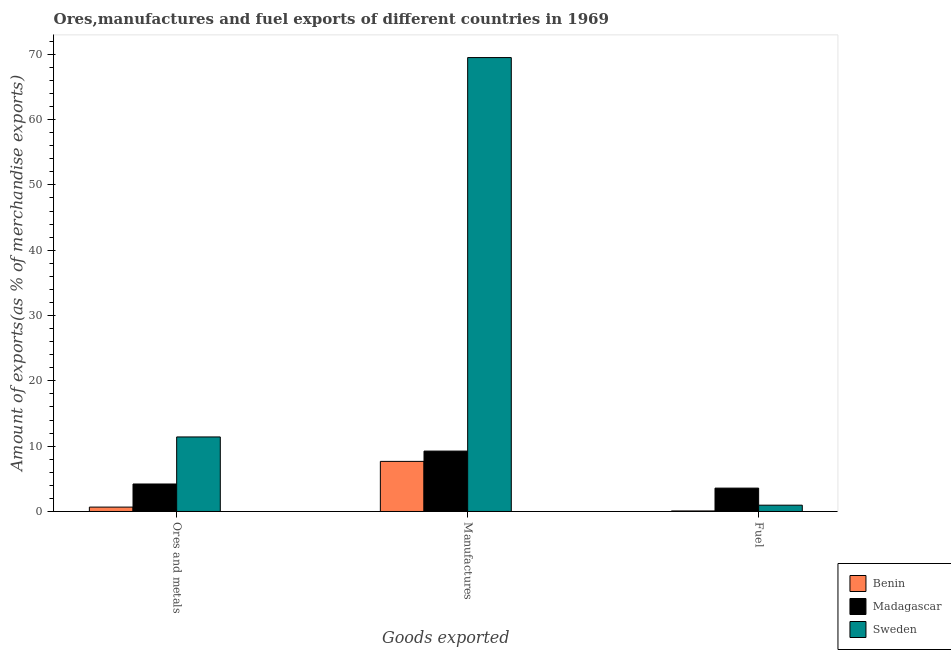How many different coloured bars are there?
Ensure brevity in your answer.  3. How many groups of bars are there?
Offer a terse response. 3. Are the number of bars per tick equal to the number of legend labels?
Your answer should be compact. Yes. Are the number of bars on each tick of the X-axis equal?
Your response must be concise. Yes. How many bars are there on the 3rd tick from the right?
Ensure brevity in your answer.  3. What is the label of the 1st group of bars from the left?
Provide a succinct answer. Ores and metals. What is the percentage of manufactures exports in Sweden?
Give a very brief answer. 69.5. Across all countries, what is the maximum percentage of ores and metals exports?
Your answer should be very brief. 11.41. Across all countries, what is the minimum percentage of manufactures exports?
Your answer should be very brief. 7.67. In which country was the percentage of ores and metals exports minimum?
Your response must be concise. Benin. What is the total percentage of manufactures exports in the graph?
Make the answer very short. 86.42. What is the difference between the percentage of fuel exports in Madagascar and that in Sweden?
Provide a succinct answer. 2.61. What is the difference between the percentage of manufactures exports in Sweden and the percentage of ores and metals exports in Madagascar?
Your answer should be compact. 65.29. What is the average percentage of fuel exports per country?
Your answer should be compact. 1.54. What is the difference between the percentage of manufactures exports and percentage of fuel exports in Madagascar?
Keep it short and to the point. 5.67. What is the ratio of the percentage of manufactures exports in Benin to that in Madagascar?
Provide a short and direct response. 0.83. What is the difference between the highest and the second highest percentage of ores and metals exports?
Offer a very short reply. 7.2. What is the difference between the highest and the lowest percentage of ores and metals exports?
Give a very brief answer. 10.74. Is the sum of the percentage of fuel exports in Sweden and Benin greater than the maximum percentage of ores and metals exports across all countries?
Keep it short and to the point. No. What does the 2nd bar from the left in Fuel represents?
Offer a very short reply. Madagascar. What does the 1st bar from the right in Manufactures represents?
Your answer should be very brief. Sweden. How many countries are there in the graph?
Offer a very short reply. 3. What is the difference between two consecutive major ticks on the Y-axis?
Keep it short and to the point. 10. Does the graph contain any zero values?
Your answer should be compact. No. Does the graph contain grids?
Offer a terse response. No. How many legend labels are there?
Offer a terse response. 3. What is the title of the graph?
Give a very brief answer. Ores,manufactures and fuel exports of different countries in 1969. Does "Nicaragua" appear as one of the legend labels in the graph?
Give a very brief answer. No. What is the label or title of the X-axis?
Make the answer very short. Goods exported. What is the label or title of the Y-axis?
Your answer should be compact. Amount of exports(as % of merchandise exports). What is the Amount of exports(as % of merchandise exports) in Benin in Ores and metals?
Make the answer very short. 0.67. What is the Amount of exports(as % of merchandise exports) in Madagascar in Ores and metals?
Your response must be concise. 4.21. What is the Amount of exports(as % of merchandise exports) in Sweden in Ores and metals?
Ensure brevity in your answer.  11.41. What is the Amount of exports(as % of merchandise exports) of Benin in Manufactures?
Make the answer very short. 7.67. What is the Amount of exports(as % of merchandise exports) in Madagascar in Manufactures?
Provide a short and direct response. 9.25. What is the Amount of exports(as % of merchandise exports) of Sweden in Manufactures?
Give a very brief answer. 69.5. What is the Amount of exports(as % of merchandise exports) in Benin in Fuel?
Your response must be concise. 0.08. What is the Amount of exports(as % of merchandise exports) of Madagascar in Fuel?
Keep it short and to the point. 3.58. What is the Amount of exports(as % of merchandise exports) of Sweden in Fuel?
Provide a succinct answer. 0.96. Across all Goods exported, what is the maximum Amount of exports(as % of merchandise exports) of Benin?
Ensure brevity in your answer.  7.67. Across all Goods exported, what is the maximum Amount of exports(as % of merchandise exports) of Madagascar?
Provide a short and direct response. 9.25. Across all Goods exported, what is the maximum Amount of exports(as % of merchandise exports) in Sweden?
Offer a very short reply. 69.5. Across all Goods exported, what is the minimum Amount of exports(as % of merchandise exports) of Benin?
Your answer should be very brief. 0.08. Across all Goods exported, what is the minimum Amount of exports(as % of merchandise exports) of Madagascar?
Make the answer very short. 3.58. Across all Goods exported, what is the minimum Amount of exports(as % of merchandise exports) in Sweden?
Provide a short and direct response. 0.96. What is the total Amount of exports(as % of merchandise exports) in Benin in the graph?
Ensure brevity in your answer.  8.42. What is the total Amount of exports(as % of merchandise exports) in Madagascar in the graph?
Your answer should be compact. 17.04. What is the total Amount of exports(as % of merchandise exports) of Sweden in the graph?
Provide a succinct answer. 81.88. What is the difference between the Amount of exports(as % of merchandise exports) in Benin in Ores and metals and that in Manufactures?
Offer a terse response. -7. What is the difference between the Amount of exports(as % of merchandise exports) in Madagascar in Ores and metals and that in Manufactures?
Provide a succinct answer. -5.04. What is the difference between the Amount of exports(as % of merchandise exports) of Sweden in Ores and metals and that in Manufactures?
Offer a very short reply. -58.09. What is the difference between the Amount of exports(as % of merchandise exports) of Benin in Ores and metals and that in Fuel?
Provide a short and direct response. 0.59. What is the difference between the Amount of exports(as % of merchandise exports) of Madagascar in Ores and metals and that in Fuel?
Provide a succinct answer. 0.63. What is the difference between the Amount of exports(as % of merchandise exports) in Sweden in Ores and metals and that in Fuel?
Keep it short and to the point. 10.45. What is the difference between the Amount of exports(as % of merchandise exports) of Benin in Manufactures and that in Fuel?
Your answer should be compact. 7.59. What is the difference between the Amount of exports(as % of merchandise exports) of Madagascar in Manufactures and that in Fuel?
Your response must be concise. 5.67. What is the difference between the Amount of exports(as % of merchandise exports) in Sweden in Manufactures and that in Fuel?
Your answer should be compact. 68.53. What is the difference between the Amount of exports(as % of merchandise exports) of Benin in Ores and metals and the Amount of exports(as % of merchandise exports) of Madagascar in Manufactures?
Provide a succinct answer. -8.58. What is the difference between the Amount of exports(as % of merchandise exports) in Benin in Ores and metals and the Amount of exports(as % of merchandise exports) in Sweden in Manufactures?
Your answer should be very brief. -68.83. What is the difference between the Amount of exports(as % of merchandise exports) in Madagascar in Ores and metals and the Amount of exports(as % of merchandise exports) in Sweden in Manufactures?
Your answer should be very brief. -65.29. What is the difference between the Amount of exports(as % of merchandise exports) in Benin in Ores and metals and the Amount of exports(as % of merchandise exports) in Madagascar in Fuel?
Provide a short and direct response. -2.91. What is the difference between the Amount of exports(as % of merchandise exports) of Benin in Ores and metals and the Amount of exports(as % of merchandise exports) of Sweden in Fuel?
Your answer should be compact. -0.29. What is the difference between the Amount of exports(as % of merchandise exports) of Madagascar in Ores and metals and the Amount of exports(as % of merchandise exports) of Sweden in Fuel?
Give a very brief answer. 3.24. What is the difference between the Amount of exports(as % of merchandise exports) of Benin in Manufactures and the Amount of exports(as % of merchandise exports) of Madagascar in Fuel?
Your response must be concise. 4.09. What is the difference between the Amount of exports(as % of merchandise exports) in Benin in Manufactures and the Amount of exports(as % of merchandise exports) in Sweden in Fuel?
Provide a succinct answer. 6.71. What is the difference between the Amount of exports(as % of merchandise exports) of Madagascar in Manufactures and the Amount of exports(as % of merchandise exports) of Sweden in Fuel?
Your response must be concise. 8.28. What is the average Amount of exports(as % of merchandise exports) of Benin per Goods exported?
Your answer should be compact. 2.81. What is the average Amount of exports(as % of merchandise exports) of Madagascar per Goods exported?
Your response must be concise. 5.68. What is the average Amount of exports(as % of merchandise exports) of Sweden per Goods exported?
Provide a succinct answer. 27.29. What is the difference between the Amount of exports(as % of merchandise exports) of Benin and Amount of exports(as % of merchandise exports) of Madagascar in Ores and metals?
Your response must be concise. -3.54. What is the difference between the Amount of exports(as % of merchandise exports) of Benin and Amount of exports(as % of merchandise exports) of Sweden in Ores and metals?
Offer a very short reply. -10.74. What is the difference between the Amount of exports(as % of merchandise exports) of Madagascar and Amount of exports(as % of merchandise exports) of Sweden in Ores and metals?
Provide a succinct answer. -7.2. What is the difference between the Amount of exports(as % of merchandise exports) of Benin and Amount of exports(as % of merchandise exports) of Madagascar in Manufactures?
Keep it short and to the point. -1.58. What is the difference between the Amount of exports(as % of merchandise exports) of Benin and Amount of exports(as % of merchandise exports) of Sweden in Manufactures?
Offer a very short reply. -61.83. What is the difference between the Amount of exports(as % of merchandise exports) of Madagascar and Amount of exports(as % of merchandise exports) of Sweden in Manufactures?
Make the answer very short. -60.25. What is the difference between the Amount of exports(as % of merchandise exports) in Benin and Amount of exports(as % of merchandise exports) in Madagascar in Fuel?
Your response must be concise. -3.5. What is the difference between the Amount of exports(as % of merchandise exports) in Benin and Amount of exports(as % of merchandise exports) in Sweden in Fuel?
Ensure brevity in your answer.  -0.88. What is the difference between the Amount of exports(as % of merchandise exports) in Madagascar and Amount of exports(as % of merchandise exports) in Sweden in Fuel?
Offer a very short reply. 2.61. What is the ratio of the Amount of exports(as % of merchandise exports) of Benin in Ores and metals to that in Manufactures?
Give a very brief answer. 0.09. What is the ratio of the Amount of exports(as % of merchandise exports) of Madagascar in Ores and metals to that in Manufactures?
Ensure brevity in your answer.  0.46. What is the ratio of the Amount of exports(as % of merchandise exports) of Sweden in Ores and metals to that in Manufactures?
Your answer should be compact. 0.16. What is the ratio of the Amount of exports(as % of merchandise exports) in Benin in Ores and metals to that in Fuel?
Your answer should be very brief. 8.24. What is the ratio of the Amount of exports(as % of merchandise exports) of Madagascar in Ores and metals to that in Fuel?
Your response must be concise. 1.18. What is the ratio of the Amount of exports(as % of merchandise exports) in Sweden in Ores and metals to that in Fuel?
Your answer should be compact. 11.83. What is the ratio of the Amount of exports(as % of merchandise exports) of Benin in Manufactures to that in Fuel?
Provide a succinct answer. 94.27. What is the ratio of the Amount of exports(as % of merchandise exports) of Madagascar in Manufactures to that in Fuel?
Give a very brief answer. 2.58. What is the ratio of the Amount of exports(as % of merchandise exports) of Sweden in Manufactures to that in Fuel?
Your response must be concise. 72.03. What is the difference between the highest and the second highest Amount of exports(as % of merchandise exports) in Benin?
Provide a succinct answer. 7. What is the difference between the highest and the second highest Amount of exports(as % of merchandise exports) in Madagascar?
Provide a succinct answer. 5.04. What is the difference between the highest and the second highest Amount of exports(as % of merchandise exports) in Sweden?
Provide a short and direct response. 58.09. What is the difference between the highest and the lowest Amount of exports(as % of merchandise exports) in Benin?
Keep it short and to the point. 7.59. What is the difference between the highest and the lowest Amount of exports(as % of merchandise exports) of Madagascar?
Give a very brief answer. 5.67. What is the difference between the highest and the lowest Amount of exports(as % of merchandise exports) in Sweden?
Your answer should be very brief. 68.53. 